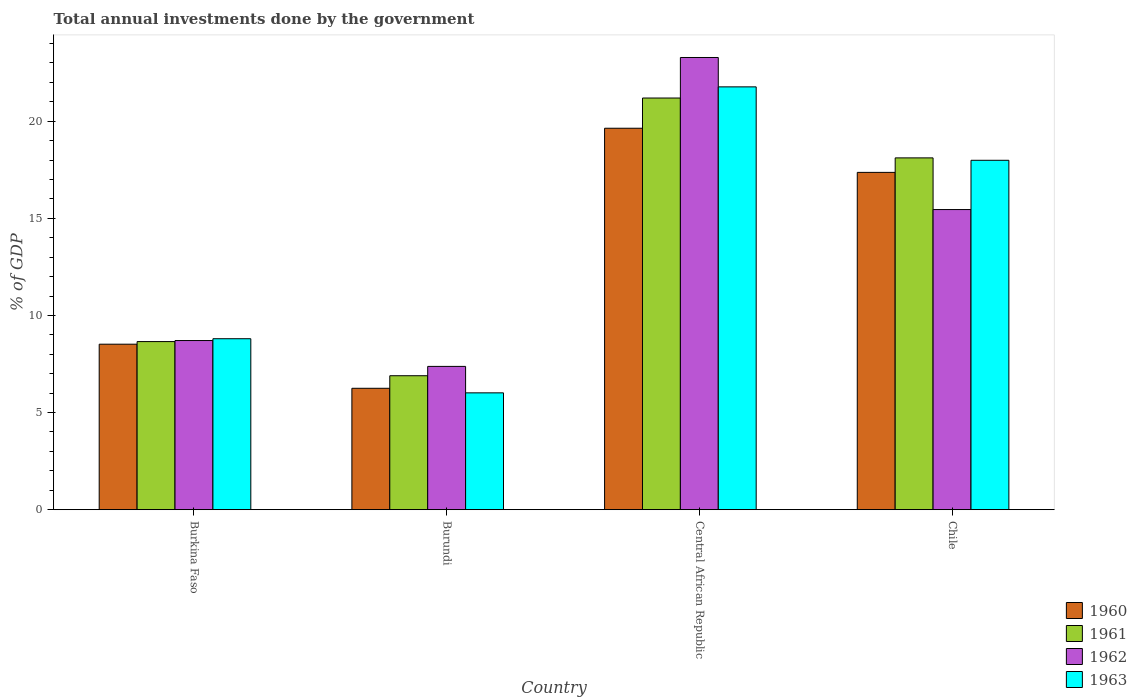How many groups of bars are there?
Give a very brief answer. 4. Are the number of bars per tick equal to the number of legend labels?
Your answer should be compact. Yes. How many bars are there on the 4th tick from the left?
Offer a terse response. 4. How many bars are there on the 2nd tick from the right?
Your answer should be compact. 4. What is the label of the 2nd group of bars from the left?
Keep it short and to the point. Burundi. What is the total annual investments done by the government in 1962 in Burundi?
Offer a very short reply. 7.38. Across all countries, what is the maximum total annual investments done by the government in 1960?
Your response must be concise. 19.64. Across all countries, what is the minimum total annual investments done by the government in 1963?
Your answer should be very brief. 6.02. In which country was the total annual investments done by the government in 1960 maximum?
Ensure brevity in your answer.  Central African Republic. In which country was the total annual investments done by the government in 1961 minimum?
Offer a very short reply. Burundi. What is the total total annual investments done by the government in 1961 in the graph?
Provide a succinct answer. 54.85. What is the difference between the total annual investments done by the government in 1960 in Burundi and that in Chile?
Offer a very short reply. -11.11. What is the difference between the total annual investments done by the government in 1961 in Burkina Faso and the total annual investments done by the government in 1963 in Chile?
Offer a terse response. -9.33. What is the average total annual investments done by the government in 1963 per country?
Offer a very short reply. 13.64. What is the difference between the total annual investments done by the government of/in 1963 and total annual investments done by the government of/in 1962 in Central African Republic?
Provide a short and direct response. -1.51. What is the ratio of the total annual investments done by the government in 1961 in Burkina Faso to that in Chile?
Offer a terse response. 0.48. Is the difference between the total annual investments done by the government in 1963 in Burkina Faso and Chile greater than the difference between the total annual investments done by the government in 1962 in Burkina Faso and Chile?
Ensure brevity in your answer.  No. What is the difference between the highest and the second highest total annual investments done by the government in 1962?
Offer a terse response. -6.74. What is the difference between the highest and the lowest total annual investments done by the government in 1961?
Offer a terse response. 14.3. Is the sum of the total annual investments done by the government in 1960 in Burundi and Central African Republic greater than the maximum total annual investments done by the government in 1962 across all countries?
Your answer should be very brief. Yes. Is it the case that in every country, the sum of the total annual investments done by the government in 1960 and total annual investments done by the government in 1962 is greater than the sum of total annual investments done by the government in 1963 and total annual investments done by the government in 1961?
Your response must be concise. No. What does the 3rd bar from the left in Chile represents?
Offer a terse response. 1962. What does the 1st bar from the right in Burkina Faso represents?
Keep it short and to the point. 1963. How many bars are there?
Make the answer very short. 16. How many countries are there in the graph?
Give a very brief answer. 4. What is the difference between two consecutive major ticks on the Y-axis?
Offer a terse response. 5. Does the graph contain grids?
Your answer should be very brief. No. Where does the legend appear in the graph?
Your answer should be very brief. Bottom right. How many legend labels are there?
Ensure brevity in your answer.  4. What is the title of the graph?
Your answer should be compact. Total annual investments done by the government. Does "1967" appear as one of the legend labels in the graph?
Your answer should be compact. No. What is the label or title of the X-axis?
Offer a very short reply. Country. What is the label or title of the Y-axis?
Your answer should be compact. % of GDP. What is the % of GDP in 1960 in Burkina Faso?
Ensure brevity in your answer.  8.52. What is the % of GDP of 1961 in Burkina Faso?
Provide a succinct answer. 8.65. What is the % of GDP of 1962 in Burkina Faso?
Ensure brevity in your answer.  8.71. What is the % of GDP of 1963 in Burkina Faso?
Your answer should be very brief. 8.8. What is the % of GDP in 1960 in Burundi?
Make the answer very short. 6.25. What is the % of GDP of 1961 in Burundi?
Provide a succinct answer. 6.9. What is the % of GDP in 1962 in Burundi?
Ensure brevity in your answer.  7.38. What is the % of GDP of 1963 in Burundi?
Your answer should be compact. 6.02. What is the % of GDP of 1960 in Central African Republic?
Offer a terse response. 19.64. What is the % of GDP in 1961 in Central African Republic?
Offer a terse response. 21.19. What is the % of GDP in 1962 in Central African Republic?
Keep it short and to the point. 23.28. What is the % of GDP of 1963 in Central African Republic?
Offer a very short reply. 21.77. What is the % of GDP in 1960 in Chile?
Your answer should be compact. 17.36. What is the % of GDP in 1961 in Chile?
Provide a succinct answer. 18.11. What is the % of GDP of 1962 in Chile?
Keep it short and to the point. 15.45. What is the % of GDP of 1963 in Chile?
Offer a terse response. 17.99. Across all countries, what is the maximum % of GDP in 1960?
Keep it short and to the point. 19.64. Across all countries, what is the maximum % of GDP in 1961?
Provide a short and direct response. 21.19. Across all countries, what is the maximum % of GDP of 1962?
Ensure brevity in your answer.  23.28. Across all countries, what is the maximum % of GDP in 1963?
Your response must be concise. 21.77. Across all countries, what is the minimum % of GDP in 1960?
Keep it short and to the point. 6.25. Across all countries, what is the minimum % of GDP of 1961?
Provide a succinct answer. 6.9. Across all countries, what is the minimum % of GDP in 1962?
Make the answer very short. 7.38. Across all countries, what is the minimum % of GDP of 1963?
Keep it short and to the point. 6.02. What is the total % of GDP of 1960 in the graph?
Your response must be concise. 51.77. What is the total % of GDP of 1961 in the graph?
Your answer should be compact. 54.85. What is the total % of GDP in 1962 in the graph?
Give a very brief answer. 54.81. What is the total % of GDP of 1963 in the graph?
Offer a terse response. 54.57. What is the difference between the % of GDP of 1960 in Burkina Faso and that in Burundi?
Provide a short and direct response. 2.27. What is the difference between the % of GDP in 1961 in Burkina Faso and that in Burundi?
Ensure brevity in your answer.  1.76. What is the difference between the % of GDP in 1962 in Burkina Faso and that in Burundi?
Provide a short and direct response. 1.33. What is the difference between the % of GDP in 1963 in Burkina Faso and that in Burundi?
Make the answer very short. 2.79. What is the difference between the % of GDP of 1960 in Burkina Faso and that in Central African Republic?
Provide a succinct answer. -11.12. What is the difference between the % of GDP of 1961 in Burkina Faso and that in Central African Republic?
Provide a succinct answer. -12.54. What is the difference between the % of GDP in 1962 in Burkina Faso and that in Central African Republic?
Your answer should be compact. -14.57. What is the difference between the % of GDP in 1963 in Burkina Faso and that in Central African Republic?
Offer a terse response. -12.97. What is the difference between the % of GDP in 1960 in Burkina Faso and that in Chile?
Your answer should be very brief. -8.84. What is the difference between the % of GDP of 1961 in Burkina Faso and that in Chile?
Make the answer very short. -9.46. What is the difference between the % of GDP of 1962 in Burkina Faso and that in Chile?
Provide a succinct answer. -6.74. What is the difference between the % of GDP of 1963 in Burkina Faso and that in Chile?
Your answer should be compact. -9.19. What is the difference between the % of GDP in 1960 in Burundi and that in Central African Republic?
Provide a short and direct response. -13.39. What is the difference between the % of GDP of 1961 in Burundi and that in Central African Republic?
Provide a short and direct response. -14.3. What is the difference between the % of GDP in 1962 in Burundi and that in Central African Republic?
Your response must be concise. -15.9. What is the difference between the % of GDP in 1963 in Burundi and that in Central African Republic?
Your response must be concise. -15.75. What is the difference between the % of GDP of 1960 in Burundi and that in Chile?
Provide a short and direct response. -11.11. What is the difference between the % of GDP of 1961 in Burundi and that in Chile?
Give a very brief answer. -11.21. What is the difference between the % of GDP of 1962 in Burundi and that in Chile?
Your answer should be very brief. -8.07. What is the difference between the % of GDP in 1963 in Burundi and that in Chile?
Your answer should be compact. -11.97. What is the difference between the % of GDP of 1960 in Central African Republic and that in Chile?
Provide a short and direct response. 2.27. What is the difference between the % of GDP in 1961 in Central African Republic and that in Chile?
Offer a very short reply. 3.08. What is the difference between the % of GDP of 1962 in Central African Republic and that in Chile?
Offer a very short reply. 7.83. What is the difference between the % of GDP of 1963 in Central African Republic and that in Chile?
Your answer should be compact. 3.78. What is the difference between the % of GDP of 1960 in Burkina Faso and the % of GDP of 1961 in Burundi?
Offer a very short reply. 1.62. What is the difference between the % of GDP of 1960 in Burkina Faso and the % of GDP of 1963 in Burundi?
Ensure brevity in your answer.  2.5. What is the difference between the % of GDP of 1961 in Burkina Faso and the % of GDP of 1962 in Burundi?
Provide a succinct answer. 1.28. What is the difference between the % of GDP of 1961 in Burkina Faso and the % of GDP of 1963 in Burundi?
Your answer should be compact. 2.64. What is the difference between the % of GDP in 1962 in Burkina Faso and the % of GDP in 1963 in Burundi?
Your answer should be compact. 2.69. What is the difference between the % of GDP in 1960 in Burkina Faso and the % of GDP in 1961 in Central African Republic?
Your response must be concise. -12.67. What is the difference between the % of GDP of 1960 in Burkina Faso and the % of GDP of 1962 in Central African Republic?
Give a very brief answer. -14.76. What is the difference between the % of GDP in 1960 in Burkina Faso and the % of GDP in 1963 in Central African Republic?
Give a very brief answer. -13.25. What is the difference between the % of GDP of 1961 in Burkina Faso and the % of GDP of 1962 in Central African Republic?
Keep it short and to the point. -14.62. What is the difference between the % of GDP of 1961 in Burkina Faso and the % of GDP of 1963 in Central African Republic?
Offer a terse response. -13.11. What is the difference between the % of GDP of 1962 in Burkina Faso and the % of GDP of 1963 in Central African Republic?
Provide a succinct answer. -13.06. What is the difference between the % of GDP in 1960 in Burkina Faso and the % of GDP in 1961 in Chile?
Offer a terse response. -9.59. What is the difference between the % of GDP of 1960 in Burkina Faso and the % of GDP of 1962 in Chile?
Provide a succinct answer. -6.93. What is the difference between the % of GDP in 1960 in Burkina Faso and the % of GDP in 1963 in Chile?
Offer a terse response. -9.47. What is the difference between the % of GDP in 1961 in Burkina Faso and the % of GDP in 1962 in Chile?
Provide a short and direct response. -6.8. What is the difference between the % of GDP of 1961 in Burkina Faso and the % of GDP of 1963 in Chile?
Your answer should be compact. -9.33. What is the difference between the % of GDP in 1962 in Burkina Faso and the % of GDP in 1963 in Chile?
Your answer should be compact. -9.28. What is the difference between the % of GDP of 1960 in Burundi and the % of GDP of 1961 in Central African Republic?
Make the answer very short. -14.94. What is the difference between the % of GDP in 1960 in Burundi and the % of GDP in 1962 in Central African Republic?
Offer a very short reply. -17.03. What is the difference between the % of GDP of 1960 in Burundi and the % of GDP of 1963 in Central African Republic?
Provide a succinct answer. -15.52. What is the difference between the % of GDP of 1961 in Burundi and the % of GDP of 1962 in Central African Republic?
Provide a short and direct response. -16.38. What is the difference between the % of GDP in 1961 in Burundi and the % of GDP in 1963 in Central African Republic?
Your response must be concise. -14.87. What is the difference between the % of GDP in 1962 in Burundi and the % of GDP in 1963 in Central African Republic?
Your answer should be very brief. -14.39. What is the difference between the % of GDP of 1960 in Burundi and the % of GDP of 1961 in Chile?
Provide a short and direct response. -11.86. What is the difference between the % of GDP in 1960 in Burundi and the % of GDP in 1962 in Chile?
Offer a terse response. -9.2. What is the difference between the % of GDP in 1960 in Burundi and the % of GDP in 1963 in Chile?
Keep it short and to the point. -11.74. What is the difference between the % of GDP of 1961 in Burundi and the % of GDP of 1962 in Chile?
Your answer should be very brief. -8.55. What is the difference between the % of GDP in 1961 in Burundi and the % of GDP in 1963 in Chile?
Provide a succinct answer. -11.09. What is the difference between the % of GDP in 1962 in Burundi and the % of GDP in 1963 in Chile?
Give a very brief answer. -10.61. What is the difference between the % of GDP of 1960 in Central African Republic and the % of GDP of 1961 in Chile?
Provide a succinct answer. 1.53. What is the difference between the % of GDP in 1960 in Central African Republic and the % of GDP in 1962 in Chile?
Give a very brief answer. 4.19. What is the difference between the % of GDP of 1960 in Central African Republic and the % of GDP of 1963 in Chile?
Offer a terse response. 1.65. What is the difference between the % of GDP of 1961 in Central African Republic and the % of GDP of 1962 in Chile?
Provide a short and direct response. 5.74. What is the difference between the % of GDP in 1961 in Central African Republic and the % of GDP in 1963 in Chile?
Offer a very short reply. 3.21. What is the difference between the % of GDP of 1962 in Central African Republic and the % of GDP of 1963 in Chile?
Provide a succinct answer. 5.29. What is the average % of GDP in 1960 per country?
Provide a short and direct response. 12.94. What is the average % of GDP of 1961 per country?
Make the answer very short. 13.71. What is the average % of GDP in 1962 per country?
Your response must be concise. 13.7. What is the average % of GDP in 1963 per country?
Keep it short and to the point. 13.64. What is the difference between the % of GDP in 1960 and % of GDP in 1961 in Burkina Faso?
Make the answer very short. -0.13. What is the difference between the % of GDP of 1960 and % of GDP of 1962 in Burkina Faso?
Make the answer very short. -0.19. What is the difference between the % of GDP in 1960 and % of GDP in 1963 in Burkina Faso?
Offer a very short reply. -0.28. What is the difference between the % of GDP in 1961 and % of GDP in 1962 in Burkina Faso?
Your response must be concise. -0.05. What is the difference between the % of GDP of 1961 and % of GDP of 1963 in Burkina Faso?
Give a very brief answer. -0.15. What is the difference between the % of GDP of 1962 and % of GDP of 1963 in Burkina Faso?
Your answer should be compact. -0.09. What is the difference between the % of GDP of 1960 and % of GDP of 1961 in Burundi?
Ensure brevity in your answer.  -0.65. What is the difference between the % of GDP in 1960 and % of GDP in 1962 in Burundi?
Your answer should be very brief. -1.13. What is the difference between the % of GDP of 1960 and % of GDP of 1963 in Burundi?
Ensure brevity in your answer.  0.23. What is the difference between the % of GDP in 1961 and % of GDP in 1962 in Burundi?
Give a very brief answer. -0.48. What is the difference between the % of GDP of 1961 and % of GDP of 1963 in Burundi?
Offer a very short reply. 0.88. What is the difference between the % of GDP in 1962 and % of GDP in 1963 in Burundi?
Provide a short and direct response. 1.36. What is the difference between the % of GDP in 1960 and % of GDP in 1961 in Central African Republic?
Your answer should be very brief. -1.56. What is the difference between the % of GDP of 1960 and % of GDP of 1962 in Central African Republic?
Keep it short and to the point. -3.64. What is the difference between the % of GDP in 1960 and % of GDP in 1963 in Central African Republic?
Offer a terse response. -2.13. What is the difference between the % of GDP in 1961 and % of GDP in 1962 in Central African Republic?
Ensure brevity in your answer.  -2.09. What is the difference between the % of GDP in 1961 and % of GDP in 1963 in Central African Republic?
Offer a terse response. -0.57. What is the difference between the % of GDP of 1962 and % of GDP of 1963 in Central African Republic?
Your answer should be compact. 1.51. What is the difference between the % of GDP of 1960 and % of GDP of 1961 in Chile?
Offer a terse response. -0.75. What is the difference between the % of GDP of 1960 and % of GDP of 1962 in Chile?
Your answer should be very brief. 1.91. What is the difference between the % of GDP of 1960 and % of GDP of 1963 in Chile?
Your answer should be very brief. -0.62. What is the difference between the % of GDP of 1961 and % of GDP of 1962 in Chile?
Your answer should be compact. 2.66. What is the difference between the % of GDP of 1961 and % of GDP of 1963 in Chile?
Give a very brief answer. 0.12. What is the difference between the % of GDP in 1962 and % of GDP in 1963 in Chile?
Give a very brief answer. -2.54. What is the ratio of the % of GDP in 1960 in Burkina Faso to that in Burundi?
Give a very brief answer. 1.36. What is the ratio of the % of GDP in 1961 in Burkina Faso to that in Burundi?
Give a very brief answer. 1.25. What is the ratio of the % of GDP in 1962 in Burkina Faso to that in Burundi?
Offer a very short reply. 1.18. What is the ratio of the % of GDP in 1963 in Burkina Faso to that in Burundi?
Your answer should be compact. 1.46. What is the ratio of the % of GDP in 1960 in Burkina Faso to that in Central African Republic?
Your answer should be very brief. 0.43. What is the ratio of the % of GDP in 1961 in Burkina Faso to that in Central African Republic?
Provide a short and direct response. 0.41. What is the ratio of the % of GDP in 1962 in Burkina Faso to that in Central African Republic?
Make the answer very short. 0.37. What is the ratio of the % of GDP of 1963 in Burkina Faso to that in Central African Republic?
Ensure brevity in your answer.  0.4. What is the ratio of the % of GDP in 1960 in Burkina Faso to that in Chile?
Offer a terse response. 0.49. What is the ratio of the % of GDP in 1961 in Burkina Faso to that in Chile?
Ensure brevity in your answer.  0.48. What is the ratio of the % of GDP in 1962 in Burkina Faso to that in Chile?
Ensure brevity in your answer.  0.56. What is the ratio of the % of GDP in 1963 in Burkina Faso to that in Chile?
Your response must be concise. 0.49. What is the ratio of the % of GDP in 1960 in Burundi to that in Central African Republic?
Your answer should be compact. 0.32. What is the ratio of the % of GDP in 1961 in Burundi to that in Central African Republic?
Provide a short and direct response. 0.33. What is the ratio of the % of GDP of 1962 in Burundi to that in Central African Republic?
Keep it short and to the point. 0.32. What is the ratio of the % of GDP of 1963 in Burundi to that in Central African Republic?
Offer a terse response. 0.28. What is the ratio of the % of GDP in 1960 in Burundi to that in Chile?
Give a very brief answer. 0.36. What is the ratio of the % of GDP in 1961 in Burundi to that in Chile?
Make the answer very short. 0.38. What is the ratio of the % of GDP in 1962 in Burundi to that in Chile?
Your response must be concise. 0.48. What is the ratio of the % of GDP of 1963 in Burundi to that in Chile?
Offer a very short reply. 0.33. What is the ratio of the % of GDP of 1960 in Central African Republic to that in Chile?
Provide a short and direct response. 1.13. What is the ratio of the % of GDP of 1961 in Central African Republic to that in Chile?
Provide a short and direct response. 1.17. What is the ratio of the % of GDP of 1962 in Central African Republic to that in Chile?
Your answer should be compact. 1.51. What is the ratio of the % of GDP in 1963 in Central African Republic to that in Chile?
Give a very brief answer. 1.21. What is the difference between the highest and the second highest % of GDP of 1960?
Make the answer very short. 2.27. What is the difference between the highest and the second highest % of GDP in 1961?
Make the answer very short. 3.08. What is the difference between the highest and the second highest % of GDP in 1962?
Provide a short and direct response. 7.83. What is the difference between the highest and the second highest % of GDP of 1963?
Your answer should be very brief. 3.78. What is the difference between the highest and the lowest % of GDP in 1960?
Make the answer very short. 13.39. What is the difference between the highest and the lowest % of GDP in 1961?
Your response must be concise. 14.3. What is the difference between the highest and the lowest % of GDP of 1962?
Make the answer very short. 15.9. What is the difference between the highest and the lowest % of GDP in 1963?
Keep it short and to the point. 15.75. 